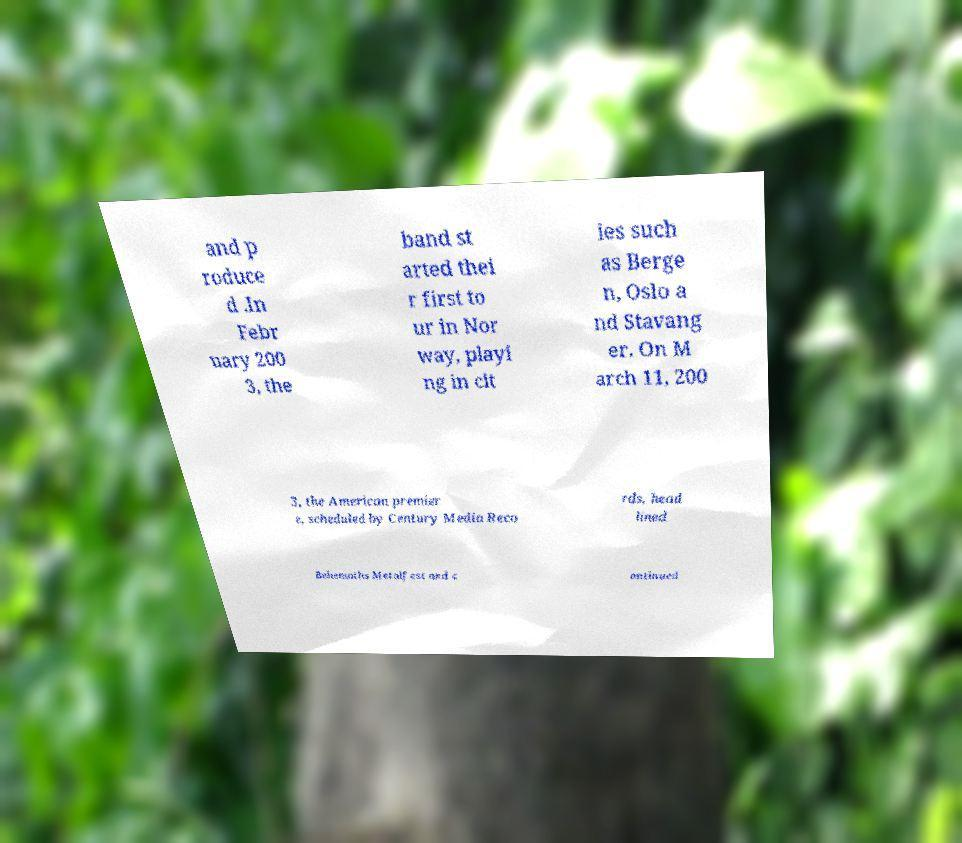I need the written content from this picture converted into text. Can you do that? and p roduce d .In Febr uary 200 3, the band st arted thei r first to ur in Nor way, playi ng in cit ies such as Berge n, Oslo a nd Stavang er. On M arch 11, 200 3, the American premier e, scheduled by Century Media Reco rds, head lined Behemoths Metalfest and c ontinued 